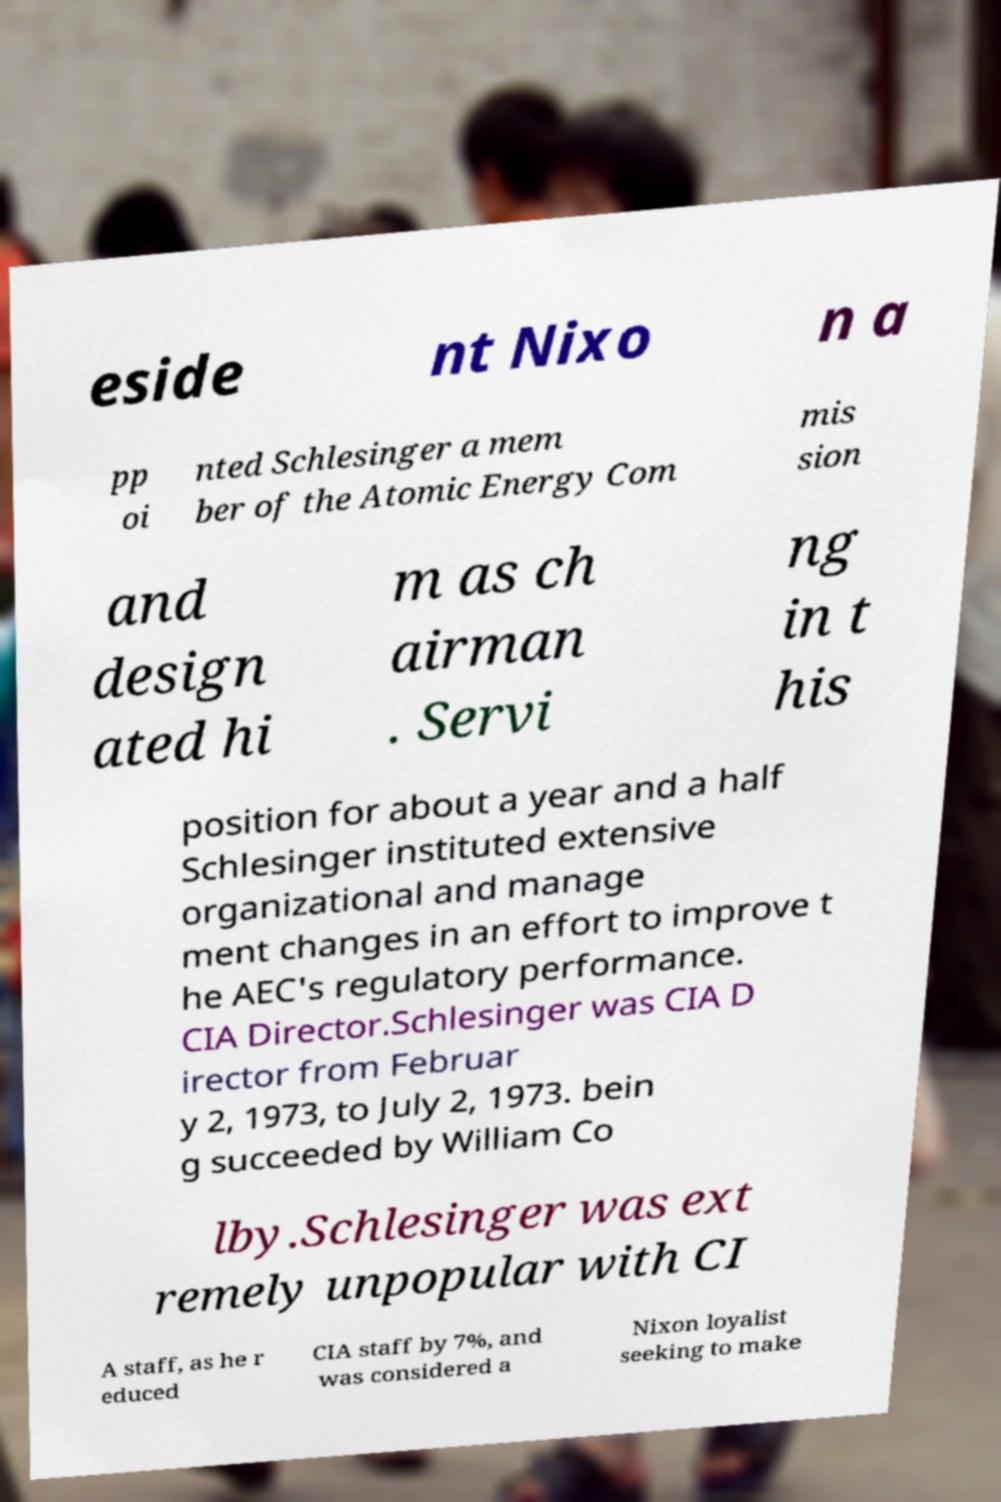Can you accurately transcribe the text from the provided image for me? eside nt Nixo n a pp oi nted Schlesinger a mem ber of the Atomic Energy Com mis sion and design ated hi m as ch airman . Servi ng in t his position for about a year and a half Schlesinger instituted extensive organizational and manage ment changes in an effort to improve t he AEC's regulatory performance. CIA Director.Schlesinger was CIA D irector from Februar y 2, 1973, to July 2, 1973. bein g succeeded by William Co lby.Schlesinger was ext remely unpopular with CI A staff, as he r educed CIA staff by 7%, and was considered a Nixon loyalist seeking to make 